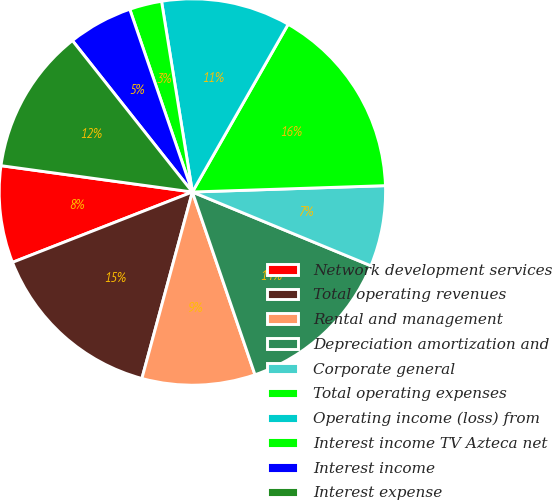Convert chart to OTSL. <chart><loc_0><loc_0><loc_500><loc_500><pie_chart><fcel>Network development services<fcel>Total operating revenues<fcel>Rental and management<fcel>Depreciation amortization and<fcel>Corporate general<fcel>Total operating expenses<fcel>Operating income (loss) from<fcel>Interest income TV Azteca net<fcel>Interest income<fcel>Interest expense<nl><fcel>8.11%<fcel>14.86%<fcel>9.46%<fcel>13.51%<fcel>6.76%<fcel>16.22%<fcel>10.81%<fcel>2.7%<fcel>5.41%<fcel>12.16%<nl></chart> 